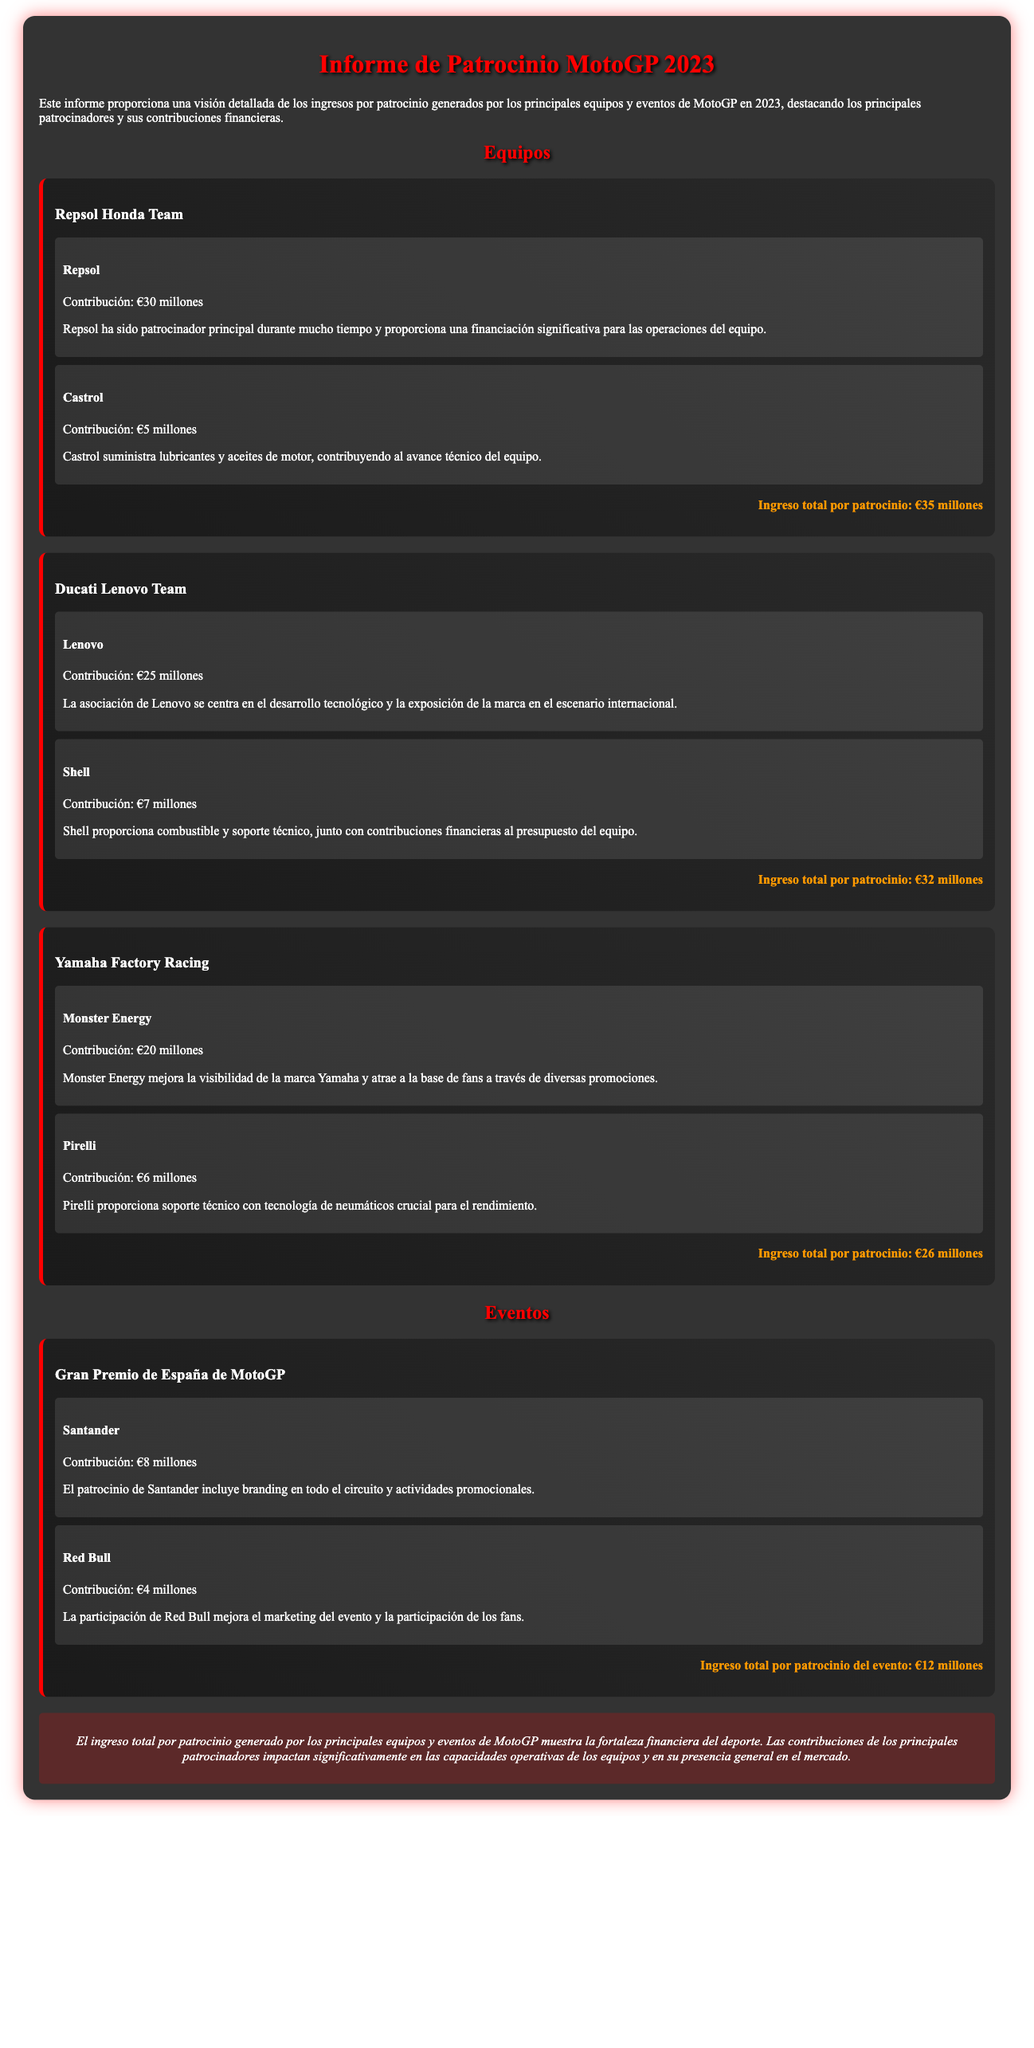¿Cuál es la contribución de Repsol al Repsol Honda Team? Repsol es el patrocinador principal y su contribución se detalla en el informe.
Answer: €30 millones ¿Cuál es el ingreso total por patrocinio del Ducati Lenovo Team? El total se calcula sumando las contribuciones de sus patrocinadores.
Answer: €32 millones ¿Qué patrocinador aporta más al Yamaha Factory Racing? El informe menciona los patrocinadores y sus contribuciones específicas.
Answer: Monster Energy ¿Cuánto contribuye Santander en el Gran Premio de España de MotoGP? La contribución se encuentra detallada en la sección del evento.
Answer: €8 millones ¿Cuál es el ingreso total por patrocinio generado por el Gran Premio de España de MotoGP? Se indica el total de ingresos por patrocinio en la sección del evento.
Answer: €12 millones ¿Cuánto contribuye Castrol al Repsol Honda Team? Se presenta la contribución de Castrol en la sección de sponsors del equipo.
Answer: €5 millones ¿Qué empresa proporciona combustible al Ducati Lenovo Team? La sección de patrocinadores del equipo detalla esta información.
Answer: Shell ¿Cuál es la contribución total de los patrocinadores de Yamaha Factory Racing? Se obtiene sumando las contribuciones de los patrocinadores listados.
Answer: €26 millones ¿Qué empresa es el patrocinador principal del Repsol Honda Team? El informe menciona a Repsol como patrocinador principal.
Answer: Repsol 